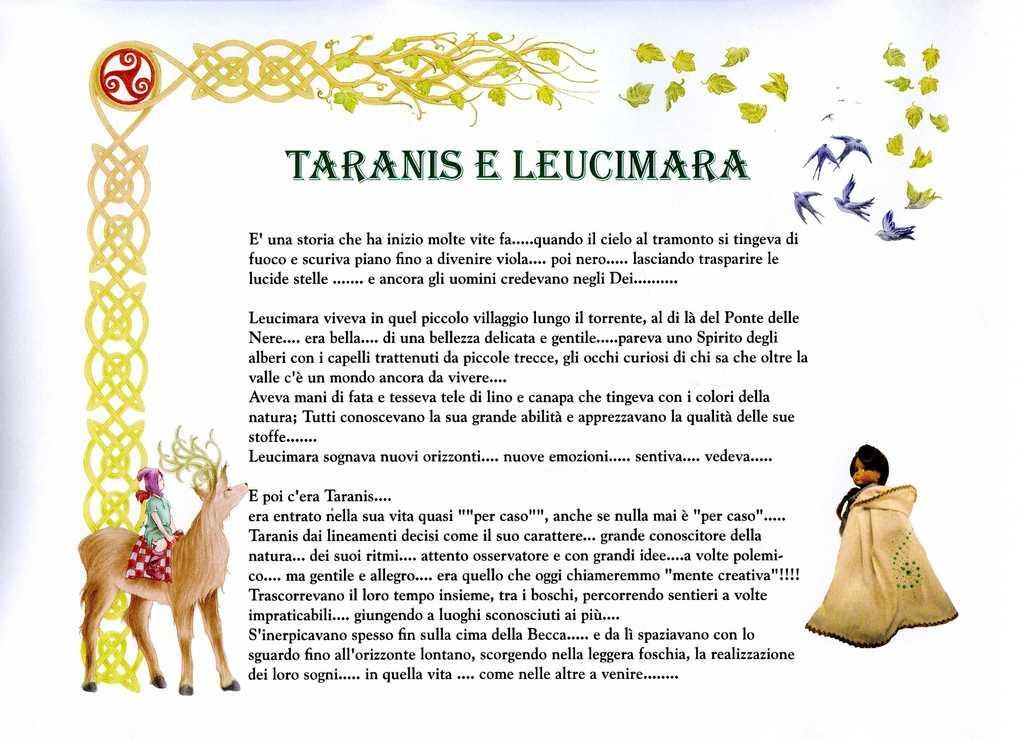Could you give a brief overview of what you see in this image? This image looks like a printed image of a book in which I can see text, birds, a person is sitting on an animal and a woman. 